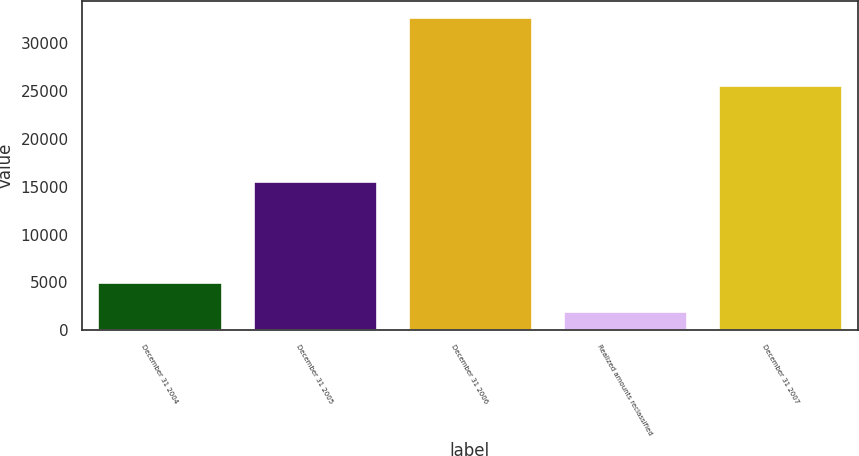Convert chart. <chart><loc_0><loc_0><loc_500><loc_500><bar_chart><fcel>December 31 2004<fcel>December 31 2005<fcel>December 31 2006<fcel>Realized amounts reclassified<fcel>December 31 2007<nl><fcel>5075.6<fcel>15580<fcel>32756<fcel>2000<fcel>25661<nl></chart> 